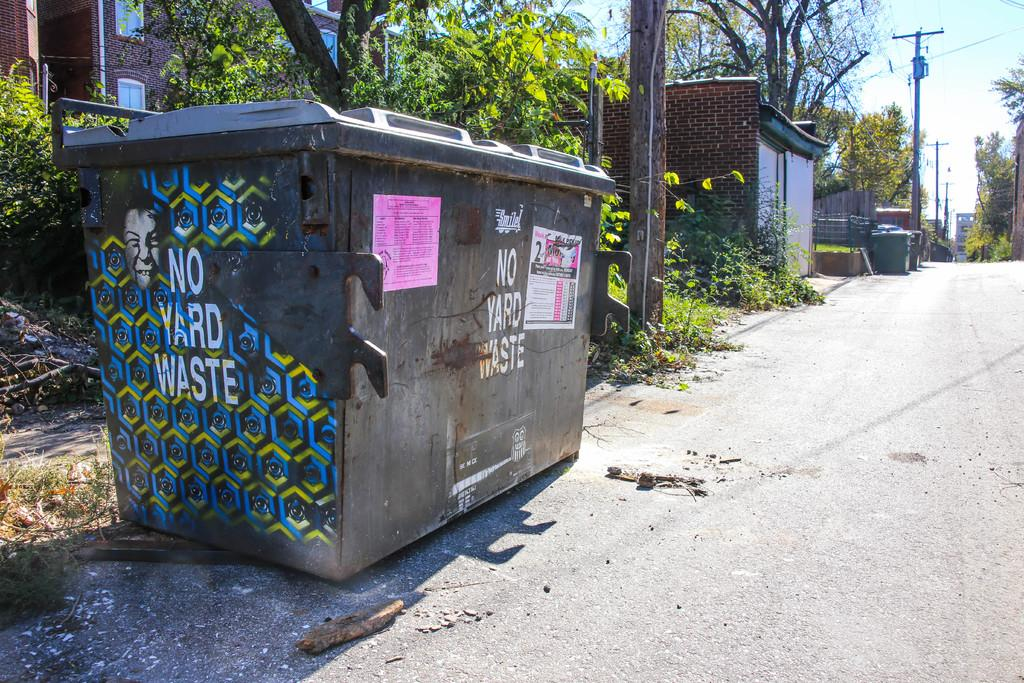<image>
Relay a brief, clear account of the picture shown. The dumpster sitting by the road says YARD WASTE 